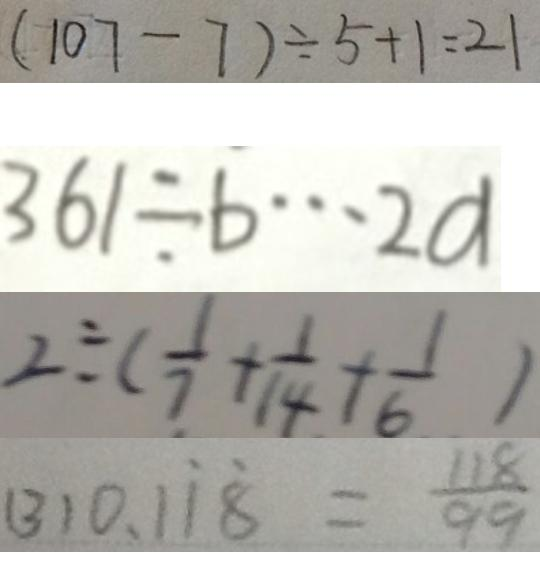<formula> <loc_0><loc_0><loc_500><loc_500>( 1 0 7 - 7 ) \div 5 + 1 = 2 1 
 3 6 1 \div b \cdots 2 a 
 2 \div ( \frac { 1 } { 7 } + \frac { 1 } { 1 4 } + \frac { 1 } { 6 } ) 
 ( 3 ) 0 . 1 \dot { 1 } \dot { 8 } = \frac { 1 1 8 } { 9 9 }</formula> 